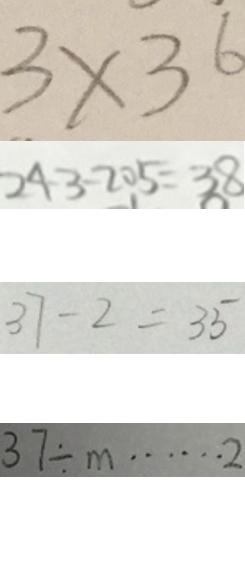<formula> <loc_0><loc_0><loc_500><loc_500>3 \times 3 6 
 2 4 3 - 2 0 5 = 3 8 
 3 7 - 2 = 3 5 
 3 7 \div m \cdots 2</formula> 